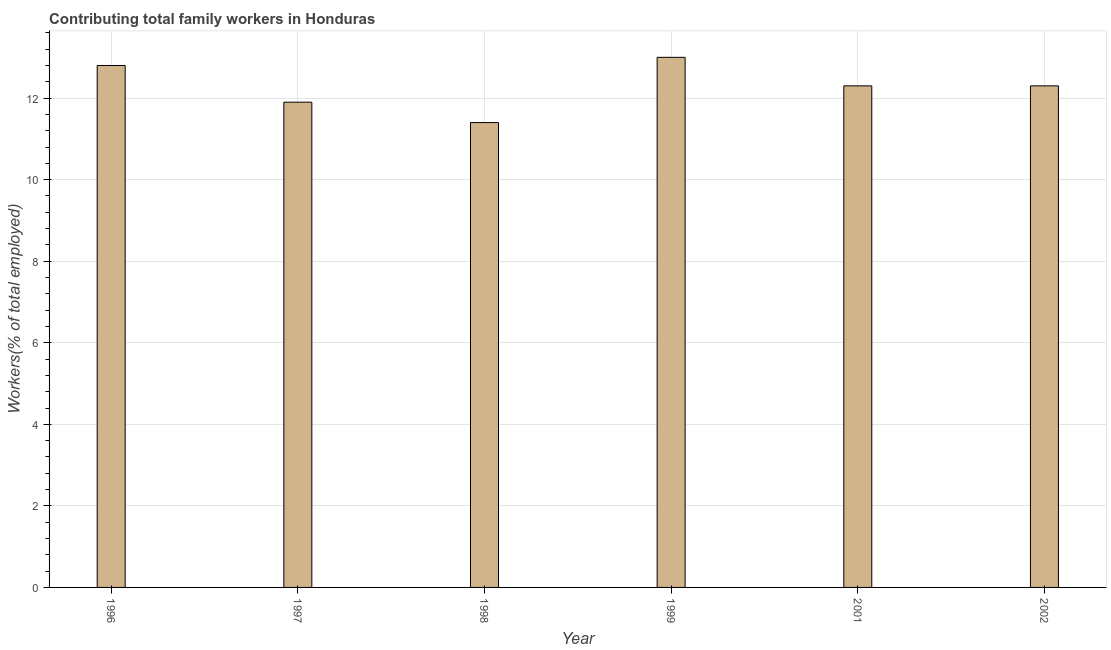What is the title of the graph?
Offer a very short reply. Contributing total family workers in Honduras. What is the label or title of the X-axis?
Provide a short and direct response. Year. What is the label or title of the Y-axis?
Make the answer very short. Workers(% of total employed). What is the contributing family workers in 1996?
Make the answer very short. 12.8. Across all years, what is the minimum contributing family workers?
Your response must be concise. 11.4. In which year was the contributing family workers maximum?
Give a very brief answer. 1999. In which year was the contributing family workers minimum?
Your answer should be compact. 1998. What is the sum of the contributing family workers?
Provide a short and direct response. 73.7. What is the average contributing family workers per year?
Offer a terse response. 12.28. What is the median contributing family workers?
Keep it short and to the point. 12.3. In how many years, is the contributing family workers greater than 9.2 %?
Provide a short and direct response. 6. What is the ratio of the contributing family workers in 1997 to that in 2002?
Keep it short and to the point. 0.97. Is the contributing family workers in 1999 less than that in 2002?
Make the answer very short. No. Is the sum of the contributing family workers in 1996 and 1999 greater than the maximum contributing family workers across all years?
Make the answer very short. Yes. What is the difference between the highest and the lowest contributing family workers?
Your response must be concise. 1.6. In how many years, is the contributing family workers greater than the average contributing family workers taken over all years?
Keep it short and to the point. 4. How many bars are there?
Provide a short and direct response. 6. Are all the bars in the graph horizontal?
Your response must be concise. No. What is the Workers(% of total employed) in 1996?
Give a very brief answer. 12.8. What is the Workers(% of total employed) of 1997?
Ensure brevity in your answer.  11.9. What is the Workers(% of total employed) in 1998?
Give a very brief answer. 11.4. What is the Workers(% of total employed) of 1999?
Offer a terse response. 13. What is the Workers(% of total employed) of 2001?
Offer a very short reply. 12.3. What is the Workers(% of total employed) of 2002?
Provide a short and direct response. 12.3. What is the difference between the Workers(% of total employed) in 1996 and 2001?
Keep it short and to the point. 0.5. What is the difference between the Workers(% of total employed) in 1997 and 1998?
Keep it short and to the point. 0.5. What is the difference between the Workers(% of total employed) in 1997 and 1999?
Provide a short and direct response. -1.1. What is the difference between the Workers(% of total employed) in 1997 and 2001?
Keep it short and to the point. -0.4. What is the difference between the Workers(% of total employed) in 1998 and 1999?
Give a very brief answer. -1.6. What is the difference between the Workers(% of total employed) in 1998 and 2001?
Keep it short and to the point. -0.9. What is the difference between the Workers(% of total employed) in 1999 and 2001?
Provide a succinct answer. 0.7. What is the difference between the Workers(% of total employed) in 1999 and 2002?
Your response must be concise. 0.7. What is the ratio of the Workers(% of total employed) in 1996 to that in 1997?
Offer a very short reply. 1.08. What is the ratio of the Workers(% of total employed) in 1996 to that in 1998?
Give a very brief answer. 1.12. What is the ratio of the Workers(% of total employed) in 1996 to that in 2001?
Offer a terse response. 1.04. What is the ratio of the Workers(% of total employed) in 1996 to that in 2002?
Your answer should be compact. 1.04. What is the ratio of the Workers(% of total employed) in 1997 to that in 1998?
Ensure brevity in your answer.  1.04. What is the ratio of the Workers(% of total employed) in 1997 to that in 1999?
Your answer should be compact. 0.92. What is the ratio of the Workers(% of total employed) in 1997 to that in 2002?
Keep it short and to the point. 0.97. What is the ratio of the Workers(% of total employed) in 1998 to that in 1999?
Give a very brief answer. 0.88. What is the ratio of the Workers(% of total employed) in 1998 to that in 2001?
Offer a terse response. 0.93. What is the ratio of the Workers(% of total employed) in 1998 to that in 2002?
Provide a short and direct response. 0.93. What is the ratio of the Workers(% of total employed) in 1999 to that in 2001?
Keep it short and to the point. 1.06. What is the ratio of the Workers(% of total employed) in 1999 to that in 2002?
Provide a succinct answer. 1.06. What is the ratio of the Workers(% of total employed) in 2001 to that in 2002?
Your answer should be compact. 1. 